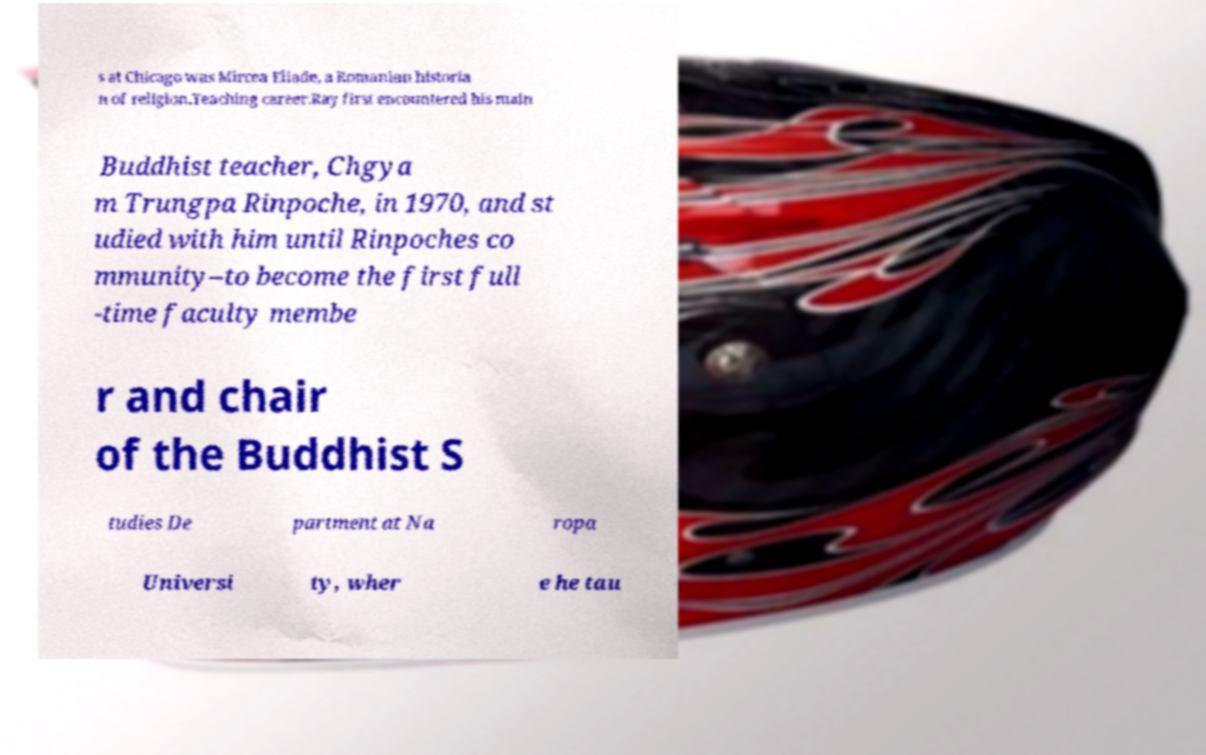What messages or text are displayed in this image? I need them in a readable, typed format. s at Chicago was Mircea Eliade, a Romanian historia n of religion.Teaching career.Ray first encountered his main Buddhist teacher, Chgya m Trungpa Rinpoche, in 1970, and st udied with him until Rinpoches co mmunity–to become the first full -time faculty membe r and chair of the Buddhist S tudies De partment at Na ropa Universi ty, wher e he tau 